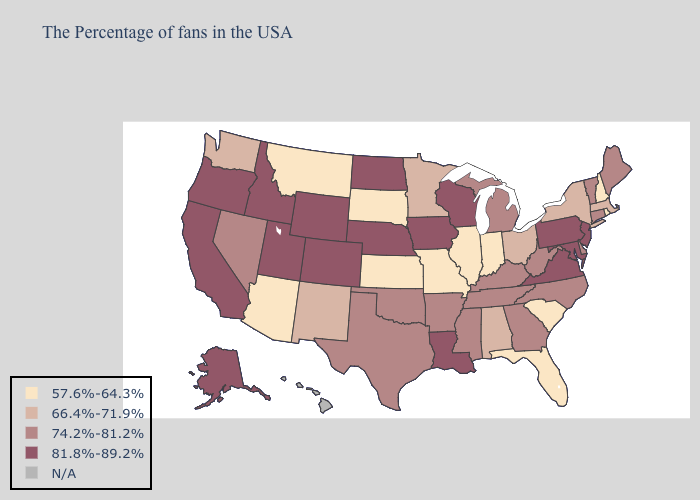Which states hav the highest value in the Northeast?
Quick response, please. New Jersey, Pennsylvania. Does the first symbol in the legend represent the smallest category?
Concise answer only. Yes. Among the states that border Texas , does New Mexico have the lowest value?
Be succinct. Yes. Name the states that have a value in the range 74.2%-81.2%?
Be succinct. Maine, Vermont, Connecticut, Delaware, North Carolina, West Virginia, Georgia, Michigan, Kentucky, Tennessee, Mississippi, Arkansas, Oklahoma, Texas, Nevada. Name the states that have a value in the range 74.2%-81.2%?
Short answer required. Maine, Vermont, Connecticut, Delaware, North Carolina, West Virginia, Georgia, Michigan, Kentucky, Tennessee, Mississippi, Arkansas, Oklahoma, Texas, Nevada. How many symbols are there in the legend?
Answer briefly. 5. Does Michigan have the lowest value in the MidWest?
Concise answer only. No. Name the states that have a value in the range 74.2%-81.2%?
Give a very brief answer. Maine, Vermont, Connecticut, Delaware, North Carolina, West Virginia, Georgia, Michigan, Kentucky, Tennessee, Mississippi, Arkansas, Oklahoma, Texas, Nevada. Does Colorado have the highest value in the USA?
Answer briefly. Yes. Does Wisconsin have the highest value in the USA?
Write a very short answer. Yes. What is the value of Idaho?
Keep it brief. 81.8%-89.2%. Does Maine have the highest value in the Northeast?
Quick response, please. No. 